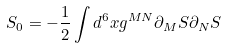Convert formula to latex. <formula><loc_0><loc_0><loc_500><loc_500>S _ { 0 } = - \frac { 1 } { 2 } \int d ^ { 6 } x g ^ { M N } \partial _ { M } S \partial _ { N } S</formula> 